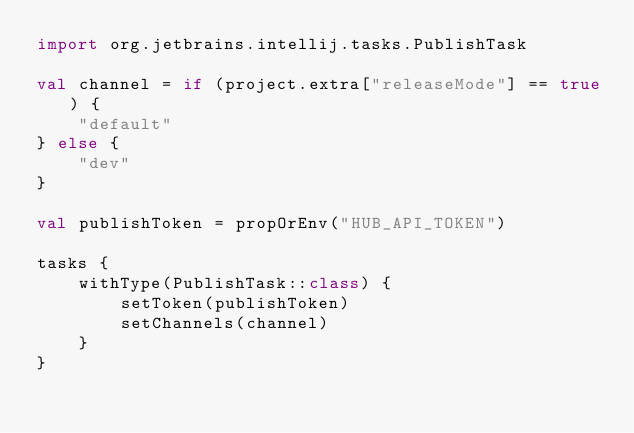<code> <loc_0><loc_0><loc_500><loc_500><_Kotlin_>import org.jetbrains.intellij.tasks.PublishTask

val channel = if (project.extra["releaseMode"] == true) {
    "default"
} else {
    "dev"
}

val publishToken = propOrEnv("HUB_API_TOKEN")

tasks {
    withType(PublishTask::class) {
        setToken(publishToken)
        setChannels(channel)
    }
}
</code> 